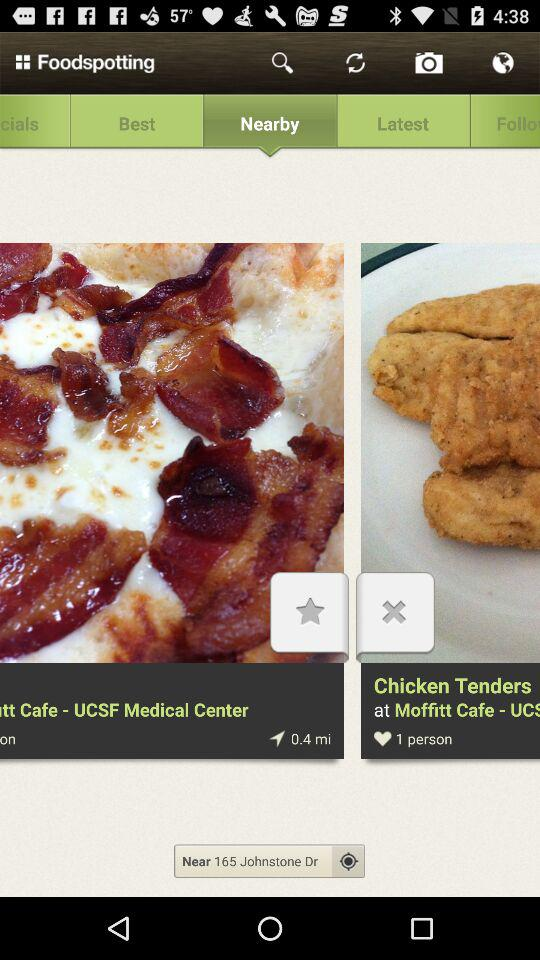How many people like chicken tenders? There is only one like. 